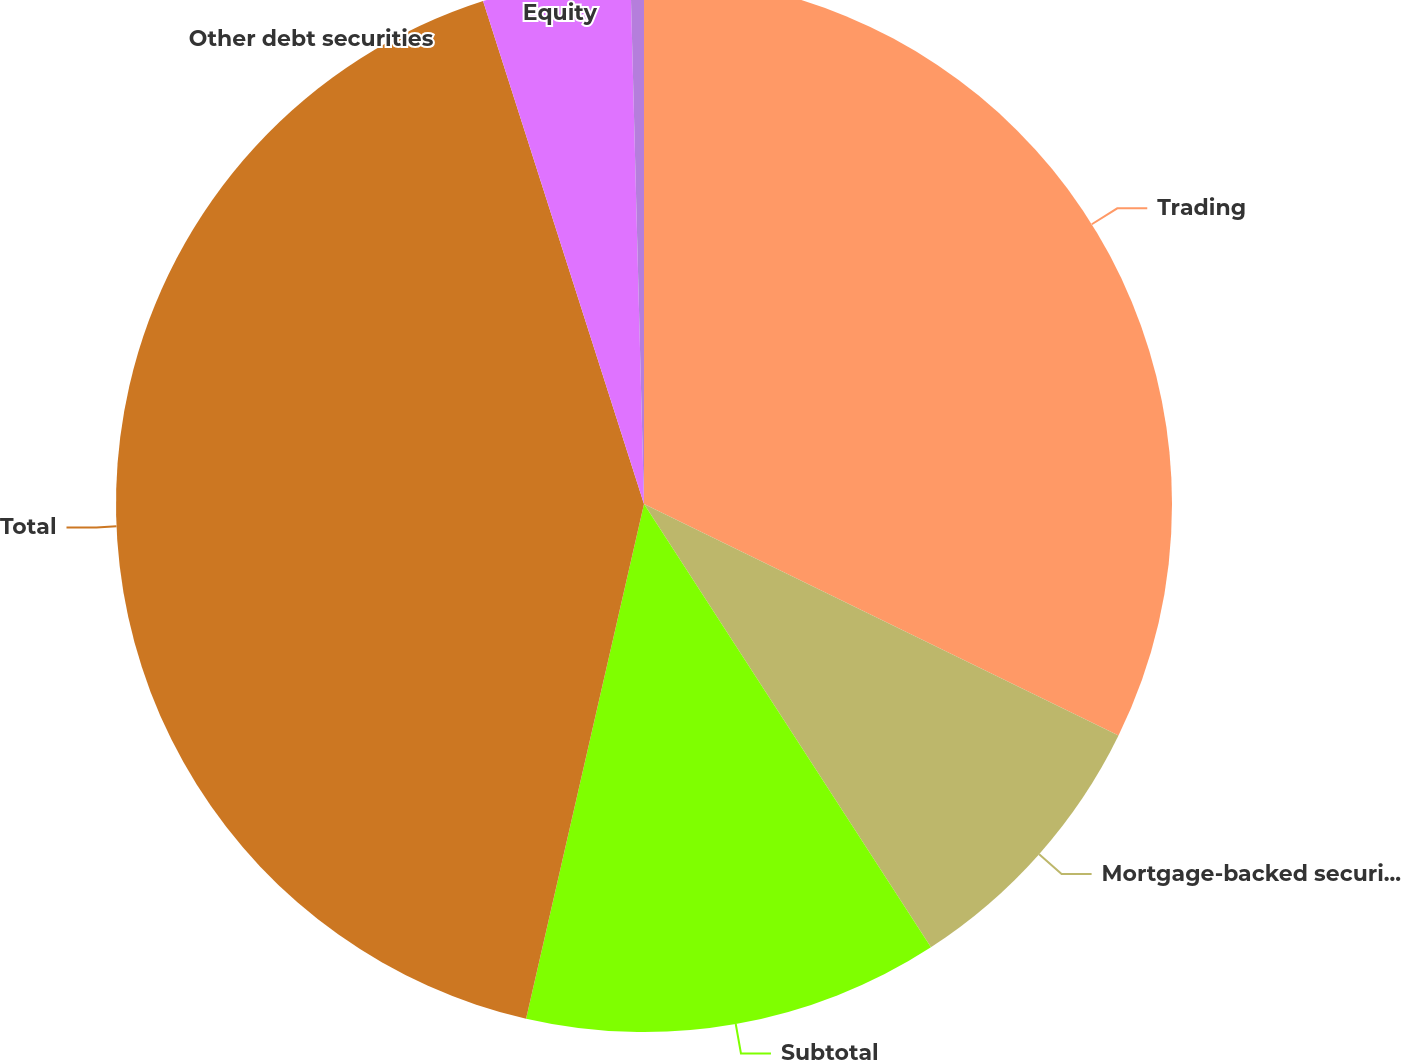<chart> <loc_0><loc_0><loc_500><loc_500><pie_chart><fcel>Trading<fcel>Mortgage-backed securities<fcel>Subtotal<fcel>Total<fcel>Other debt securities<fcel>Equity<nl><fcel>32.23%<fcel>8.63%<fcel>12.73%<fcel>41.49%<fcel>4.52%<fcel>0.41%<nl></chart> 